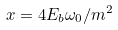<formula> <loc_0><loc_0><loc_500><loc_500>x = 4 E _ { b } \omega _ { 0 } / m ^ { 2 }</formula> 